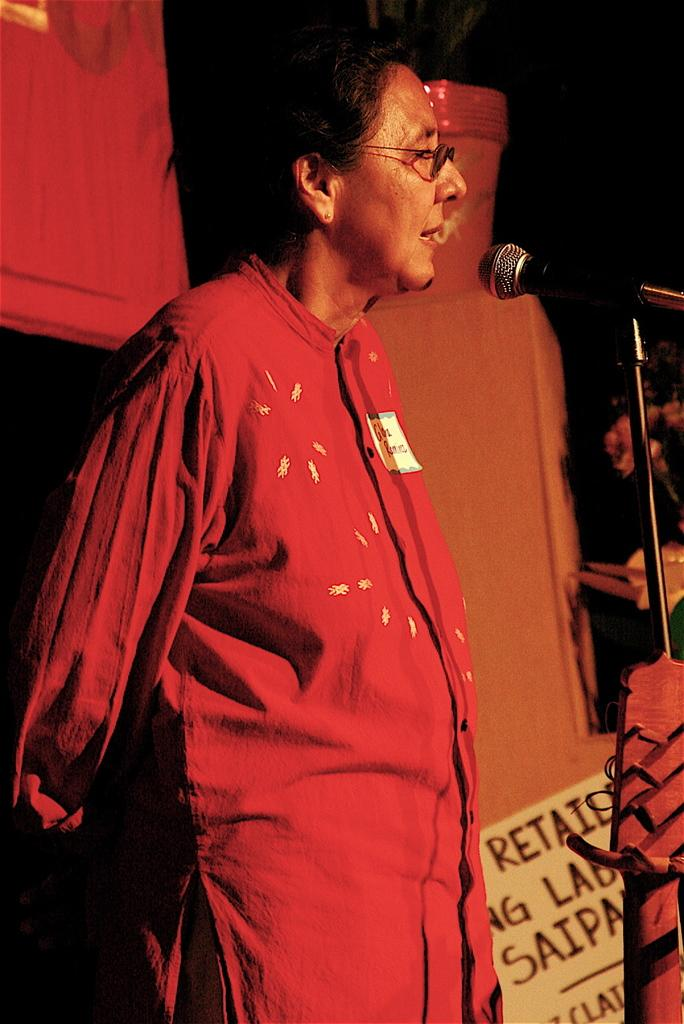What is the main subject of the image? There is a person standing in the image. What object is in front of the person? There is a microphone in front of the person. What can be seen on the board in the image? There is a board with text in the image. Can you describe any other objects in the image? There are other unspecified objects in the image. What type of texture can be seen on the building in the image? There is no building present in the image; it features a person standing with a microphone and a board with text. 